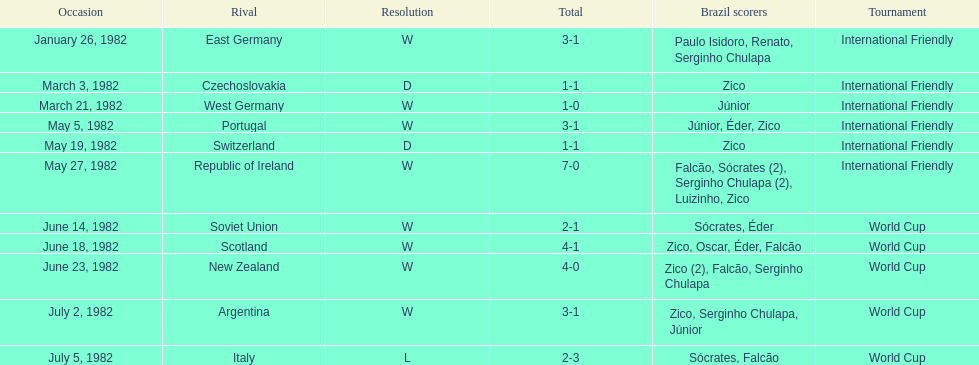Did brazil score more goals against the soviet union or portugal in 1982? Portugal. 